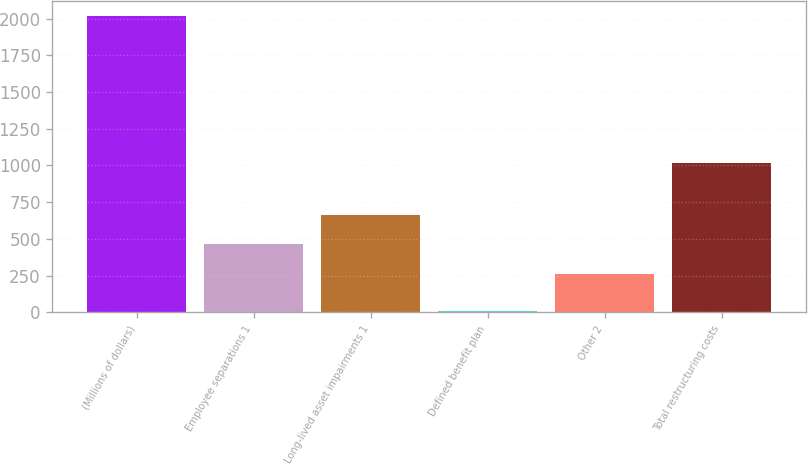Convert chart to OTSL. <chart><loc_0><loc_0><loc_500><loc_500><bar_chart><fcel>(Millions of dollars)<fcel>Employee separations 1<fcel>Long-lived asset impairments 1<fcel>Defined benefit plan<fcel>Other 2<fcel>Total restructuring costs<nl><fcel>2016<fcel>462.9<fcel>663.8<fcel>7<fcel>262<fcel>1019<nl></chart> 